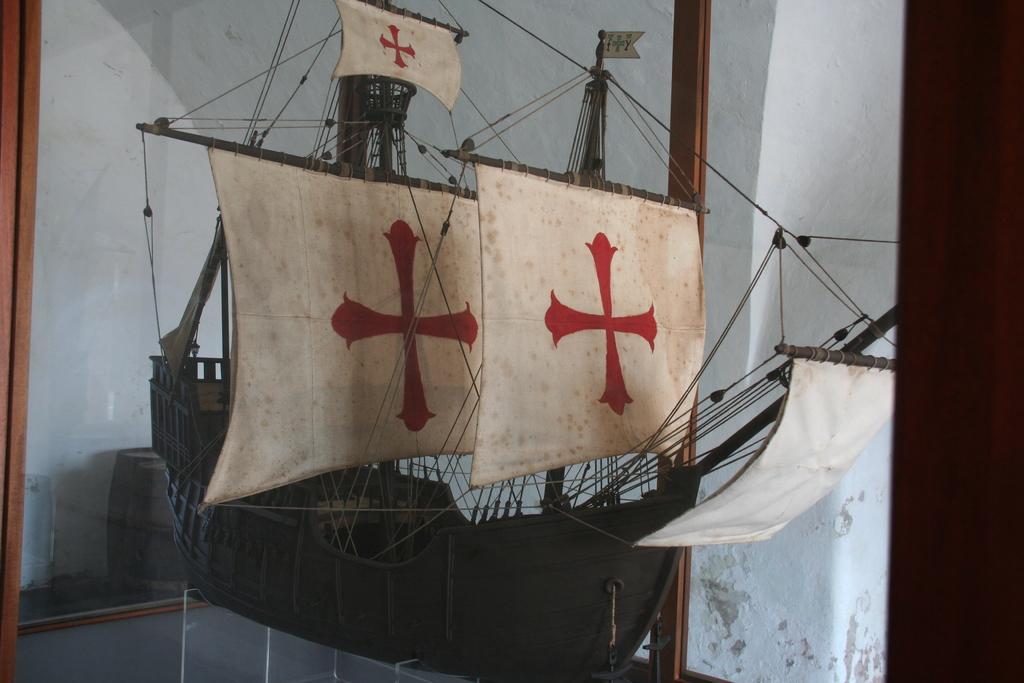Describe this image in one or two sentences. This picture seems to be clicked inside the room. In the center we can see the sculpture of a ship with the flags and the cables. In the background we can see the wall, glass, barrel and some other items. 